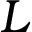<formula> <loc_0><loc_0><loc_500><loc_500>L</formula> 